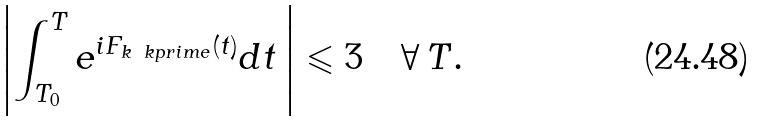Convert formula to latex. <formula><loc_0><loc_0><loc_500><loc_500>\left | \int _ { T _ { 0 } } ^ { T } e ^ { i F _ { k \ k p r i m e } ( t ) } d t \, \right | \leqslant 3 \quad \forall \, T .</formula> 